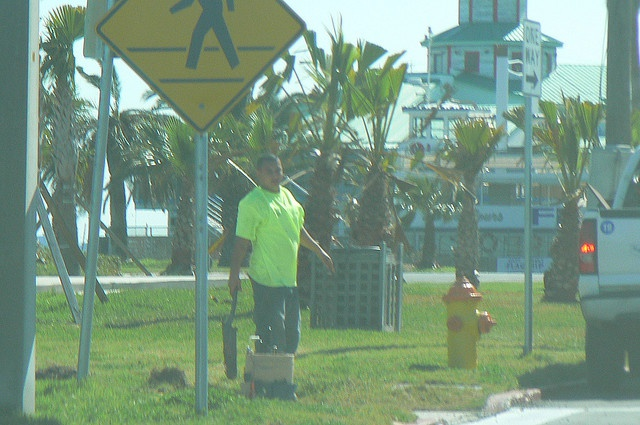Describe the objects in this image and their specific colors. I can see truck in teal and darkgray tones, people in teal and lightgreen tones, and fire hydrant in teal, olive, and gray tones in this image. 